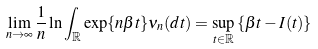<formula> <loc_0><loc_0><loc_500><loc_500>\lim _ { n \rightarrow \infty } \frac { 1 } { n } \ln \int _ { \mathbb { R } } \exp \{ n \beta t \} \nu _ { n } ( d t ) = \sup _ { t \in \mathbb { R } } \left \{ \beta t - I ( t ) \right \}</formula> 